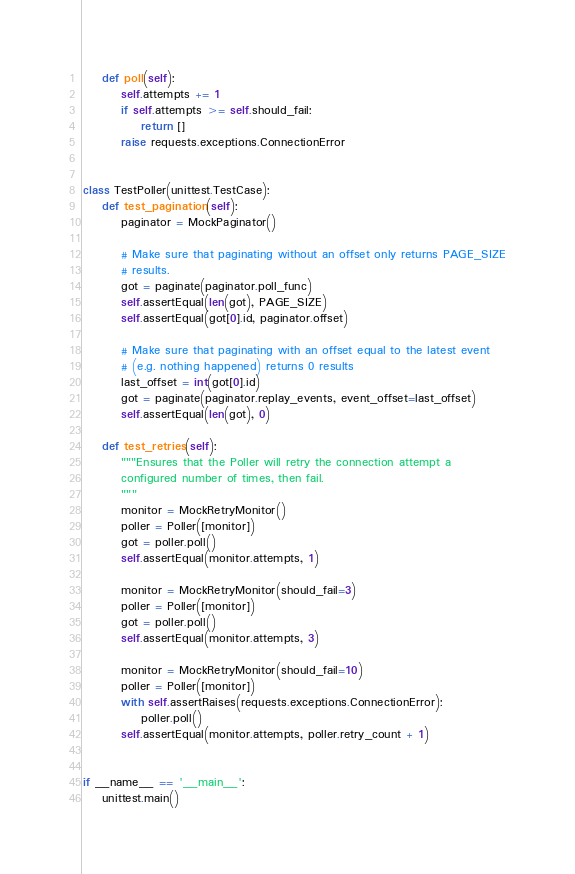<code> <loc_0><loc_0><loc_500><loc_500><_Python_>    def poll(self):
        self.attempts += 1
        if self.attempts >= self.should_fail:
            return []
        raise requests.exceptions.ConnectionError


class TestPoller(unittest.TestCase):
    def test_pagination(self):
        paginator = MockPaginator()

        # Make sure that paginating without an offset only returns PAGE_SIZE
        # results.
        got = paginate(paginator.poll_func)
        self.assertEqual(len(got), PAGE_SIZE)
        self.assertEqual(got[0].id, paginator.offset)

        # Make sure that paginating with an offset equal to the latest event
        # (e.g. nothing happened) returns 0 results
        last_offset = int(got[0].id)
        got = paginate(paginator.replay_events, event_offset=last_offset)
        self.assertEqual(len(got), 0)

    def test_retries(self):
        """Ensures that the Poller will retry the connection attempt a
        configured number of times, then fail.
        """
        monitor = MockRetryMonitor()
        poller = Poller([monitor])
        got = poller.poll()
        self.assertEqual(monitor.attempts, 1)

        monitor = MockRetryMonitor(should_fail=3)
        poller = Poller([monitor])
        got = poller.poll()
        self.assertEqual(monitor.attempts, 3)

        monitor = MockRetryMonitor(should_fail=10)
        poller = Poller([monitor])
        with self.assertRaises(requests.exceptions.ConnectionError):
            poller.poll()
        self.assertEqual(monitor.attempts, poller.retry_count + 1)


if __name__ == '__main__':
    unittest.main()
</code> 